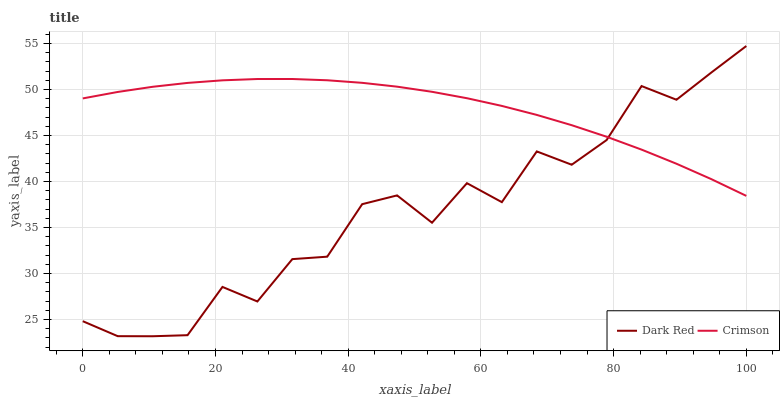Does Dark Red have the minimum area under the curve?
Answer yes or no. Yes. Does Crimson have the maximum area under the curve?
Answer yes or no. Yes. Does Dark Red have the maximum area under the curve?
Answer yes or no. No. Is Crimson the smoothest?
Answer yes or no. Yes. Is Dark Red the roughest?
Answer yes or no. Yes. Is Dark Red the smoothest?
Answer yes or no. No. Does Dark Red have the highest value?
Answer yes or no. Yes. Does Crimson intersect Dark Red?
Answer yes or no. Yes. Is Crimson less than Dark Red?
Answer yes or no. No. Is Crimson greater than Dark Red?
Answer yes or no. No. 